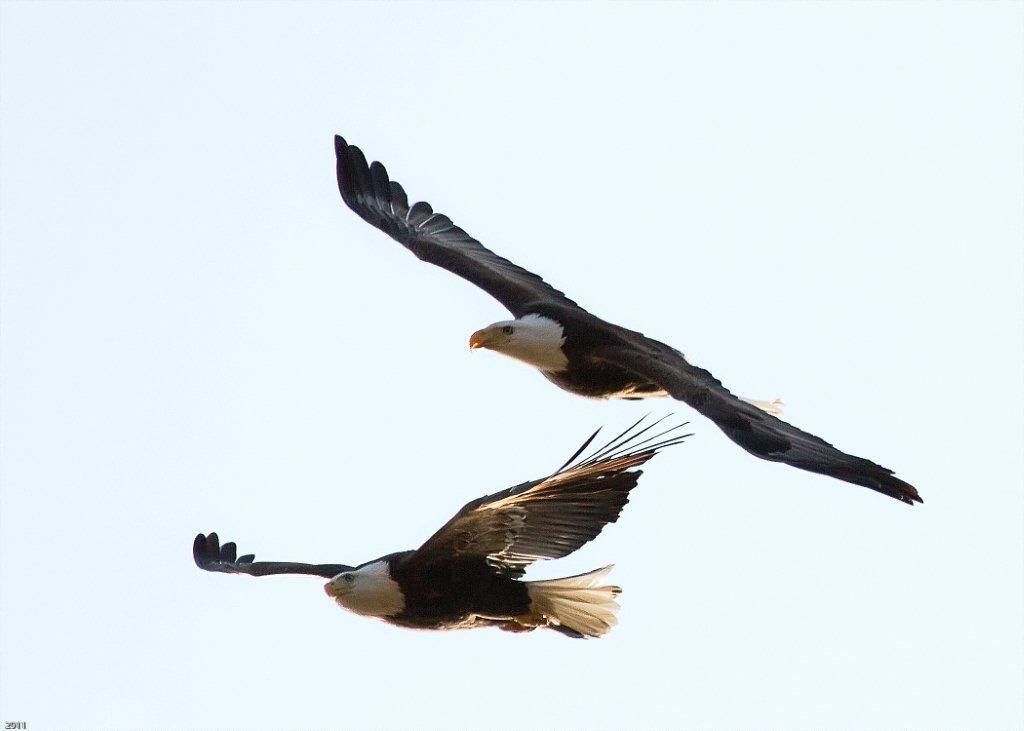What is happening in the sky in the image? There are two birds flying in the air in the image. What can be seen in the background of the image? The sky is visible in the background of the image. What type of bread can be seen floating in the sky in the image? There is no bread present in the image; it only features two birds flying in the sky. 